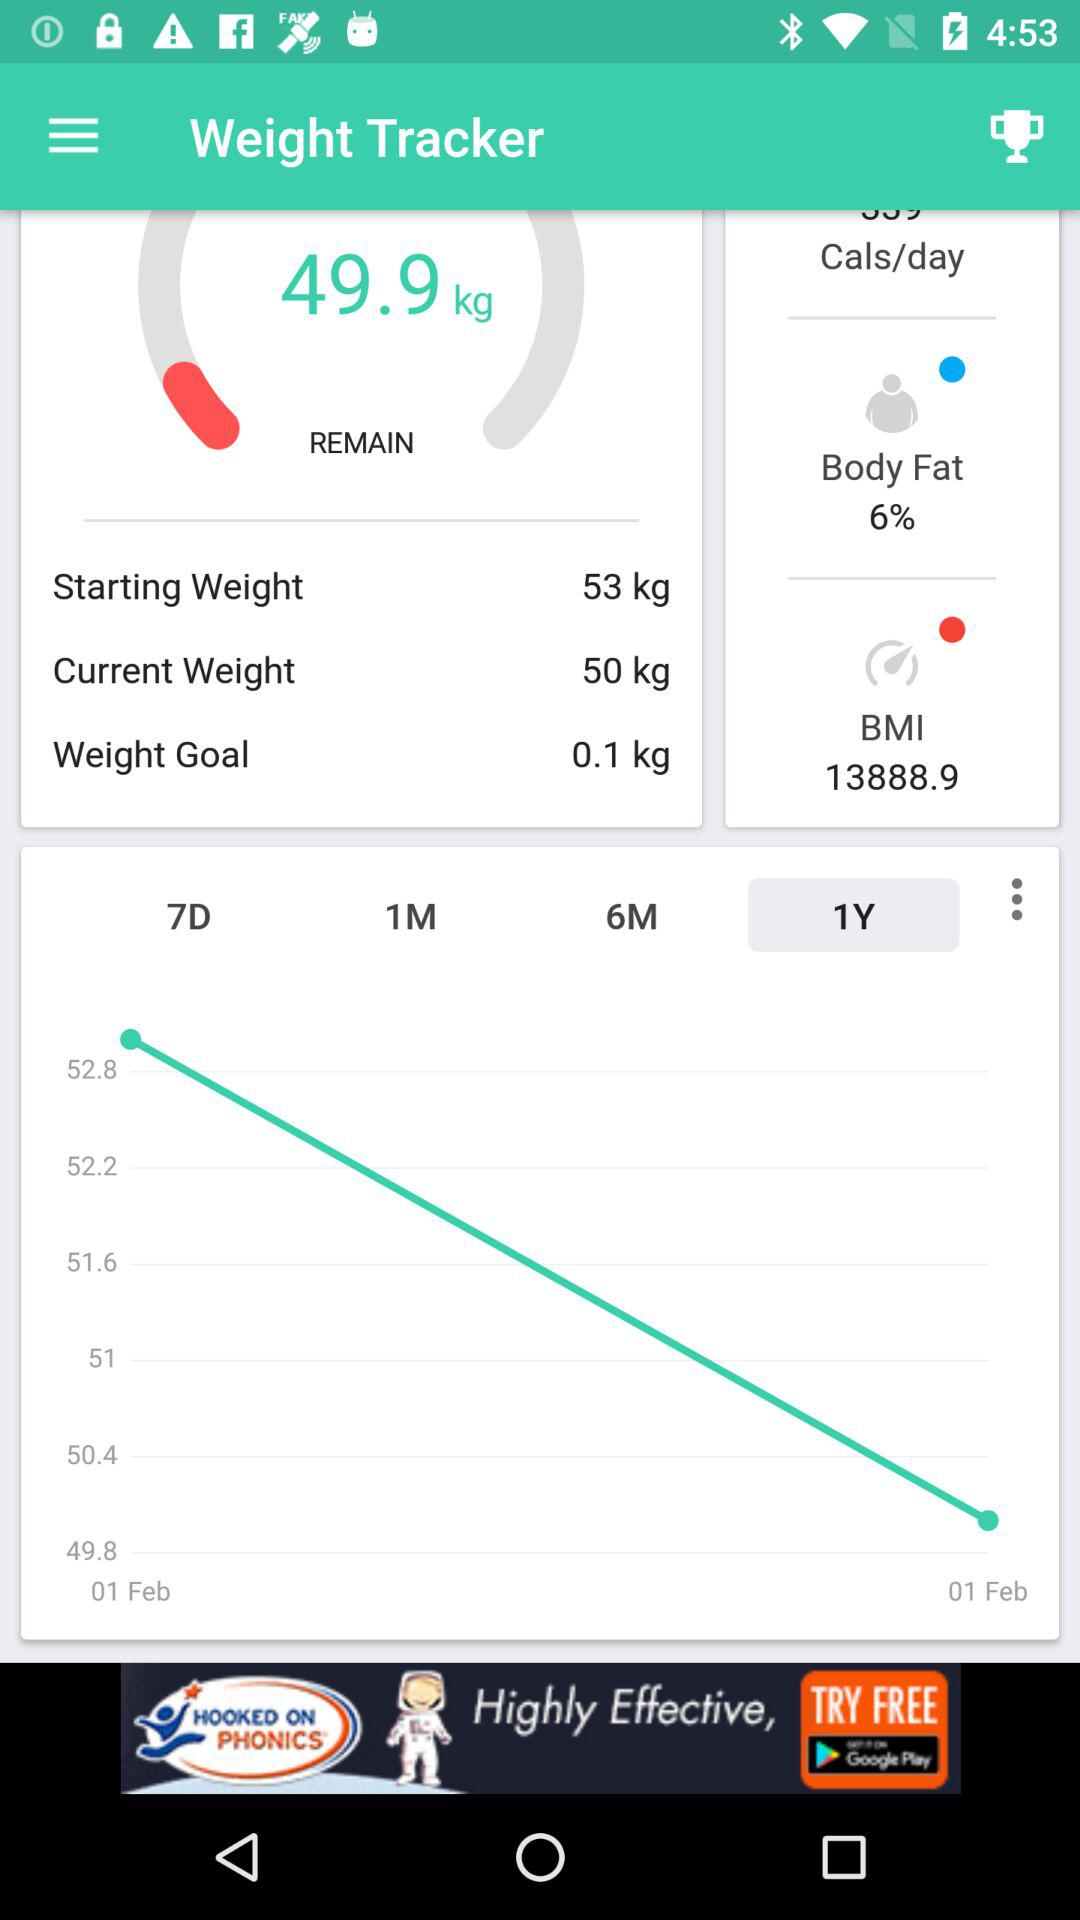What is the starting weight? The starting weight is 53 kg. 